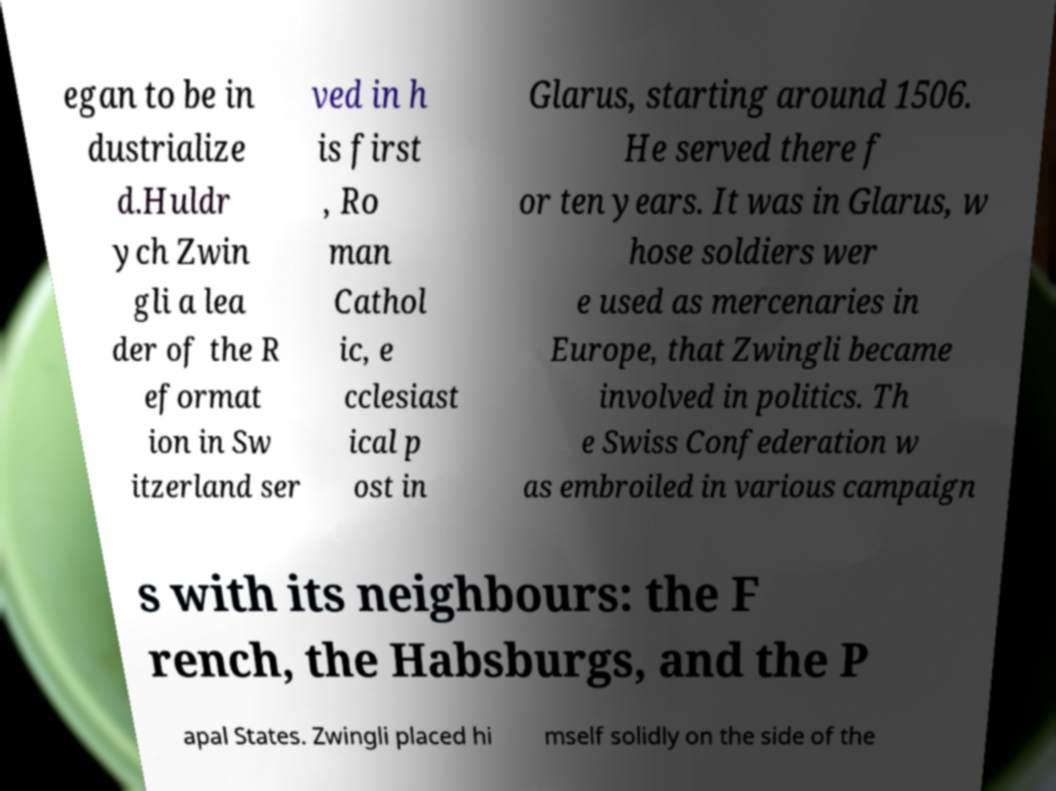Please read and relay the text visible in this image. What does it say? egan to be in dustrialize d.Huldr ych Zwin gli a lea der of the R eformat ion in Sw itzerland ser ved in h is first , Ro man Cathol ic, e cclesiast ical p ost in Glarus, starting around 1506. He served there f or ten years. It was in Glarus, w hose soldiers wer e used as mercenaries in Europe, that Zwingli became involved in politics. Th e Swiss Confederation w as embroiled in various campaign s with its neighbours: the F rench, the Habsburgs, and the P apal States. Zwingli placed hi mself solidly on the side of the 